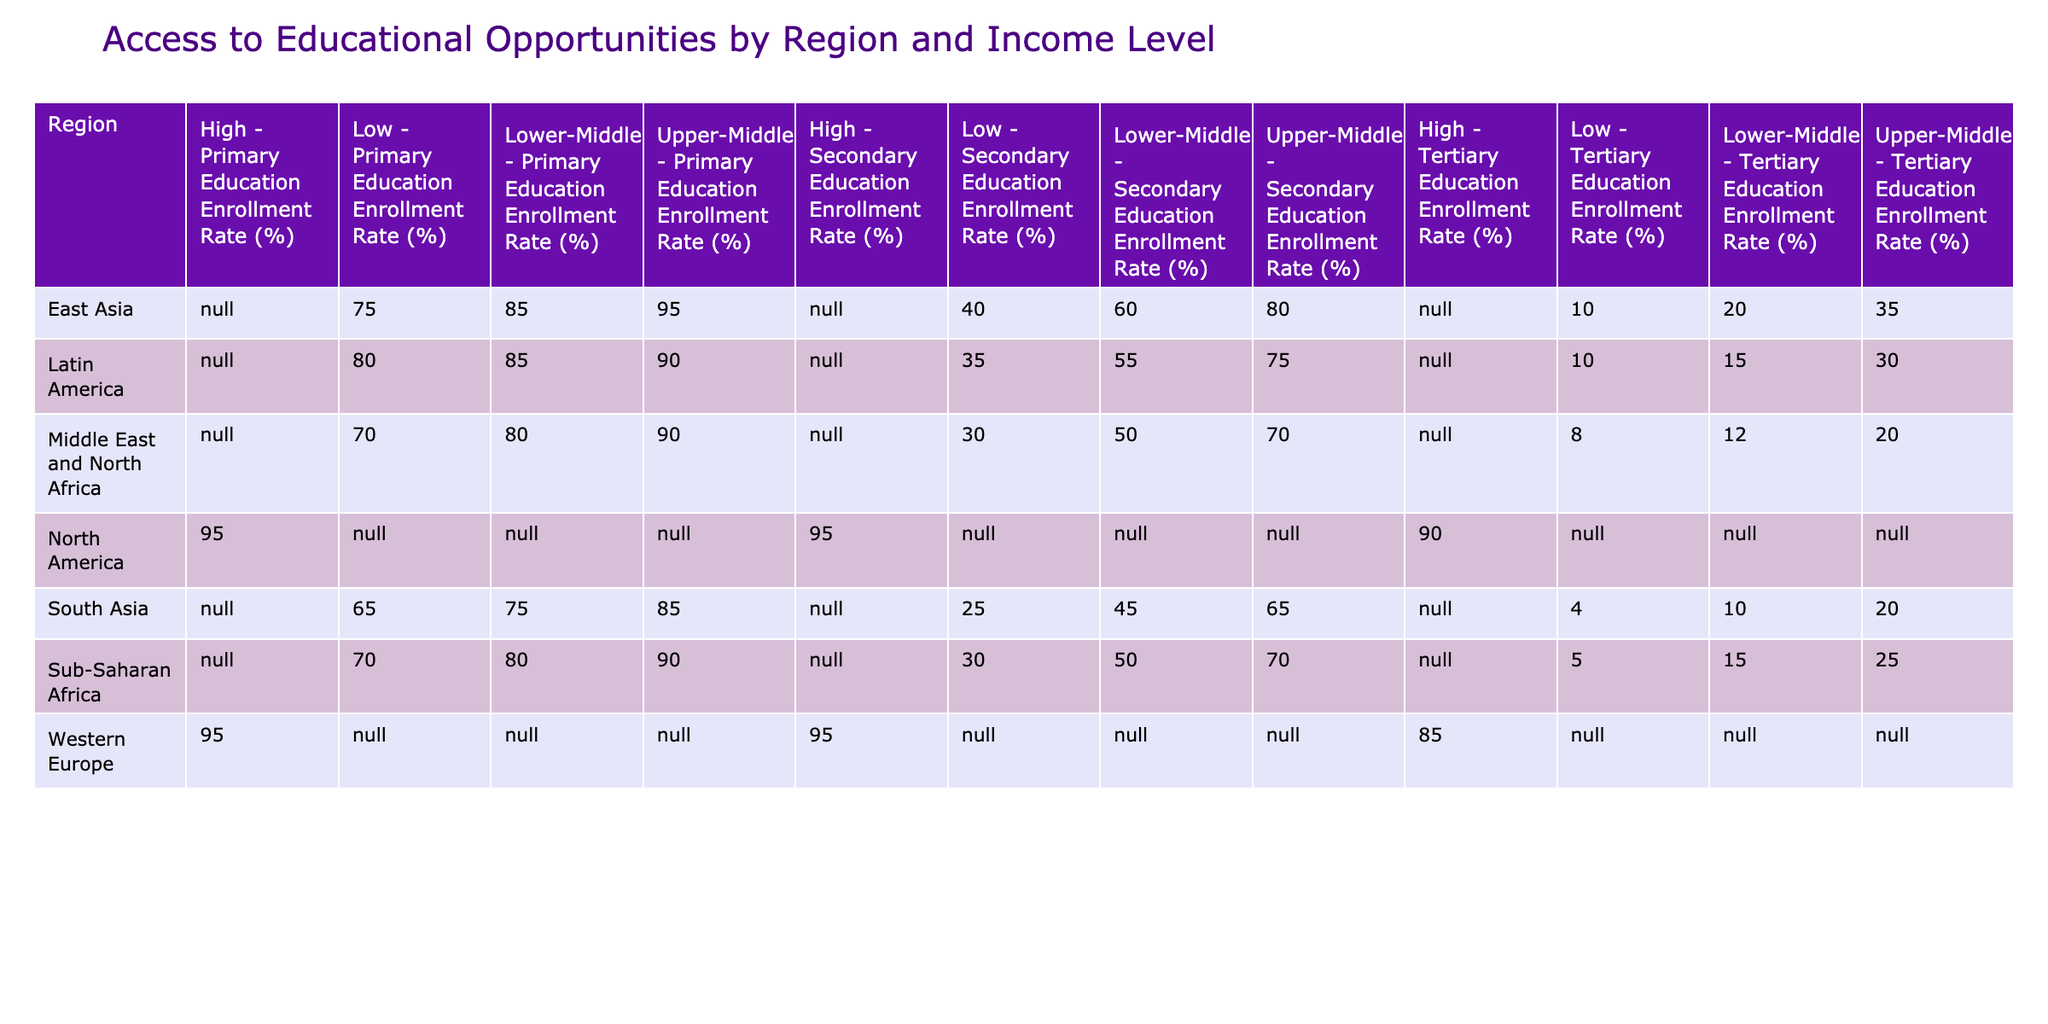What is the Primary Education Enrollment Rate for Upper-Middle Income in Sub-Saharan Africa? The table shows that the Primary Education Enrollment Rate for Upper-Middle Income in Sub-Saharan Africa is listed next to that income level in the respective row, which is 90%.
Answer: 90% Which region has the lowest Secondary Education Enrollment Rate among Low Income levels? By comparing the Secondary Education Enrollment Rates for each region under Low Income, South Asia has the lowest rate at 25%.
Answer: 25% What is the difference in Tertiary Education Enrollment Rates between East Asia and South Asia for Lower-Middle Income? From the table, East Asia's Tertiary Education Enrollment Rate for Lower-Middle Income is 20%, while South Asia's is 10%. The difference is calculated as 20% - 10% = 10%.
Answer: 10% Is the Primary Education Enrollment Rate higher in Latin America or Middle East and North Africa for Lower-Middle Income? Looking at the table, Latin America has a Primary Education Enrollment Rate of 85%, while Middle East and North Africa has 80% for Lower-Middle Income. Therefore, Latin America has a higher rate.
Answer: Yes What is the average Secondary Education Enrollment Rate of Upper-Middle Income regions? The Upper-Middle Income Secondary Education Enrollment Rates are 70% (Sub-Saharan Africa), 80% (East Asia), 65% (South Asia), 75% (Latin America), and 70% (Middle East and North Africa). Adding these gives 70 + 80 + 65 + 75 + 70 = 360. Dividing by 5 gives an average of 72%.
Answer: 72% Which region has the highest Tertiary Education Enrollment Rate among all income levels? By reviewing all income levels across regions for Tertiary Education Enrollment Rates, Western Europe has the highest rate at 85%.
Answer: 85% Do any regions show a Tertiary Education Enrollment Rate of 0%? The table lists Tertiary Education Enrollment Rates for all regions, and the lowest listed is 4% from South Asia (Low Income), indicating that no region has a Tertiary Education Enrollment Rate of 0%.
Answer: No 